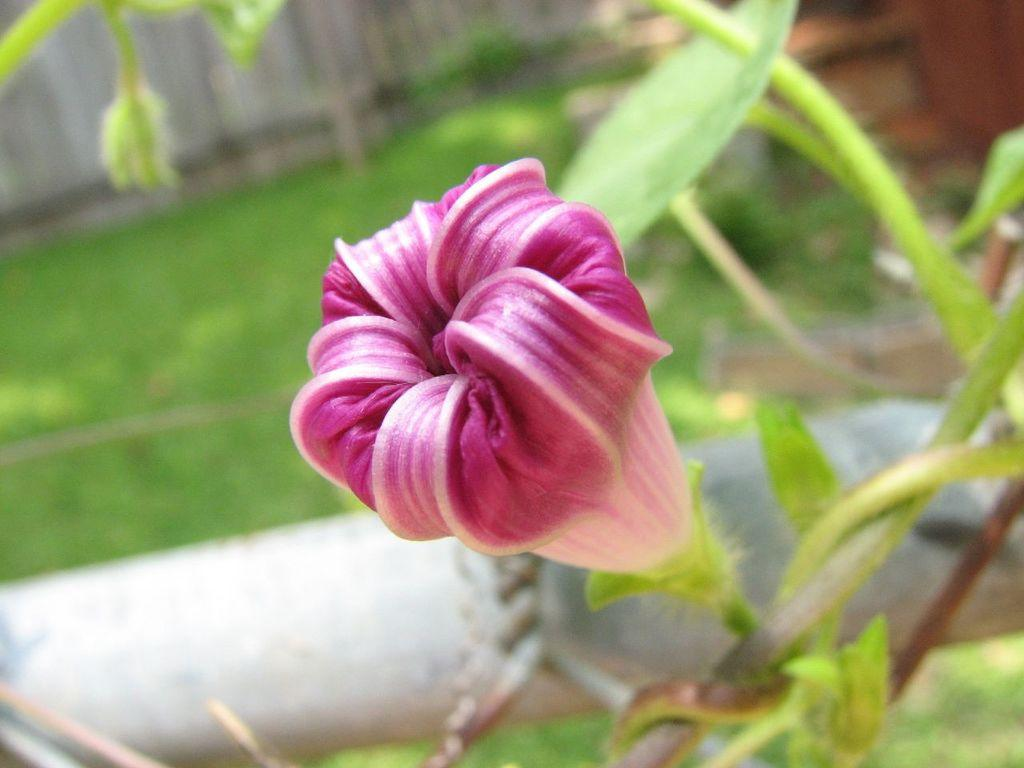What type of plant is in the image? There is a flower plant in the image. What color is the flower on the plant? The flower is purple. Can you describe the background of the image? The background of the image is blurred. What type of drug is the flower plant producing in the image? There is no indication in the image that the flower plant is producing any drugs. 